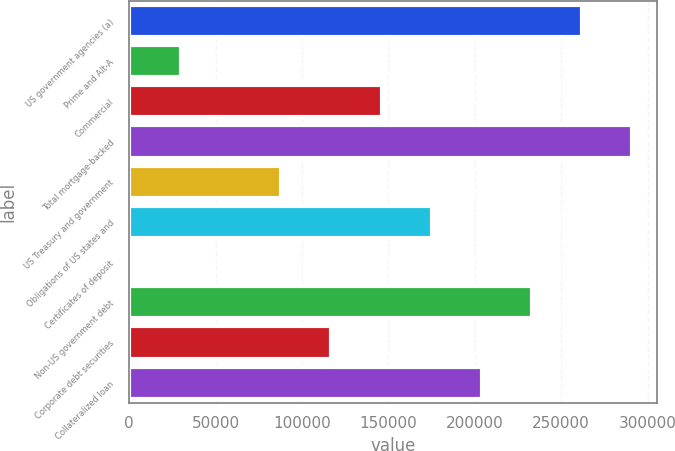Convert chart. <chart><loc_0><loc_0><loc_500><loc_500><bar_chart><fcel>US government agencies (a)<fcel>Prime and Alt-A<fcel>Commercial<fcel>Total mortgage-backed<fcel>US Treasury and government<fcel>Obligations of US states and<fcel>Certificates of deposit<fcel>Non-US government debt<fcel>Corporate debt securities<fcel>Collateralized loan<nl><fcel>261991<fcel>30090.6<fcel>146041<fcel>290979<fcel>88065.8<fcel>175029<fcel>1103<fcel>233004<fcel>117053<fcel>204016<nl></chart> 